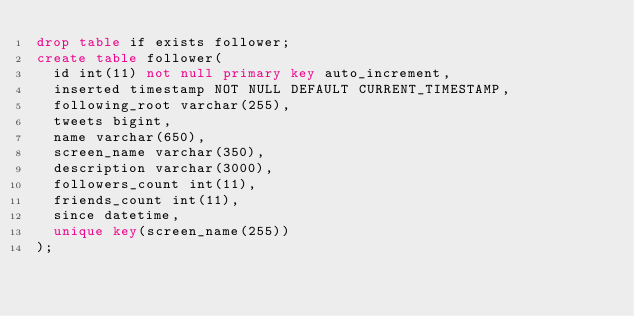Convert code to text. <code><loc_0><loc_0><loc_500><loc_500><_SQL_>drop table if exists follower;
create table follower(
  id int(11) not null primary key auto_increment,
  inserted timestamp NOT NULL DEFAULT CURRENT_TIMESTAMP,
  following_root varchar(255),
  tweets bigint,
  name varchar(650),
  screen_name varchar(350),
  description varchar(3000),
  followers_count int(11),
  friends_count int(11),
  since datetime,
  unique key(screen_name(255))
);

</code> 